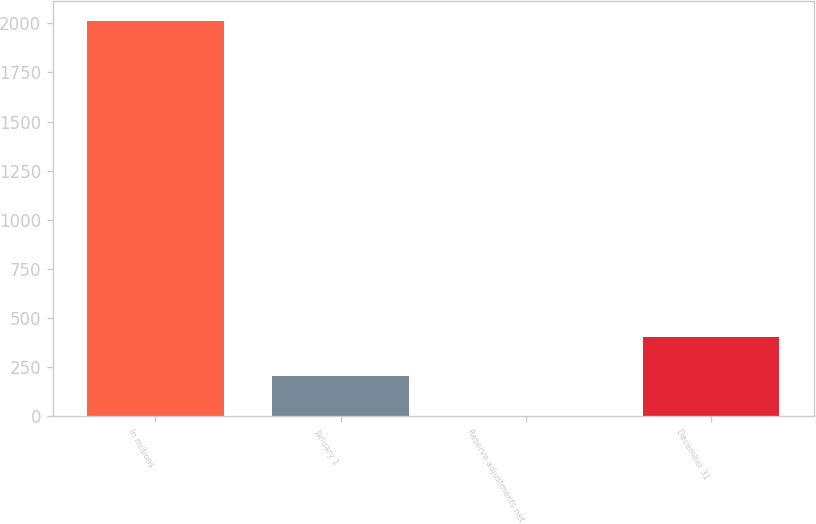<chart> <loc_0><loc_0><loc_500><loc_500><bar_chart><fcel>In millions<fcel>January 1<fcel>Reserve adjustments net<fcel>December 31<nl><fcel>2014<fcel>203.2<fcel>2<fcel>404.4<nl></chart> 